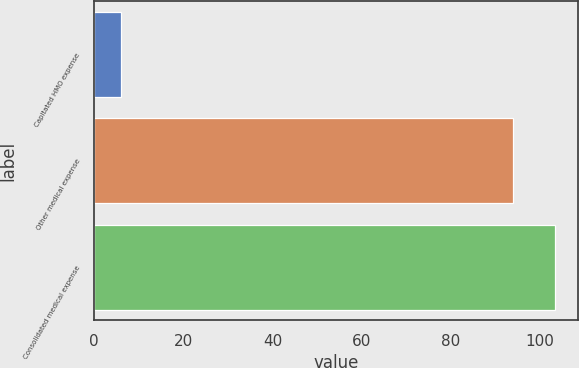<chart> <loc_0><loc_0><loc_500><loc_500><bar_chart><fcel>Capitated HMO expense<fcel>Other medical expense<fcel>Consolidated medical expense<nl><fcel>6<fcel>94<fcel>103.4<nl></chart> 